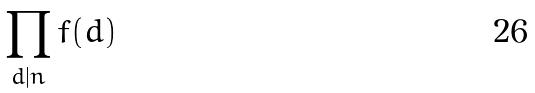<formula> <loc_0><loc_0><loc_500><loc_500>\prod _ { d | n } f ( d )</formula> 